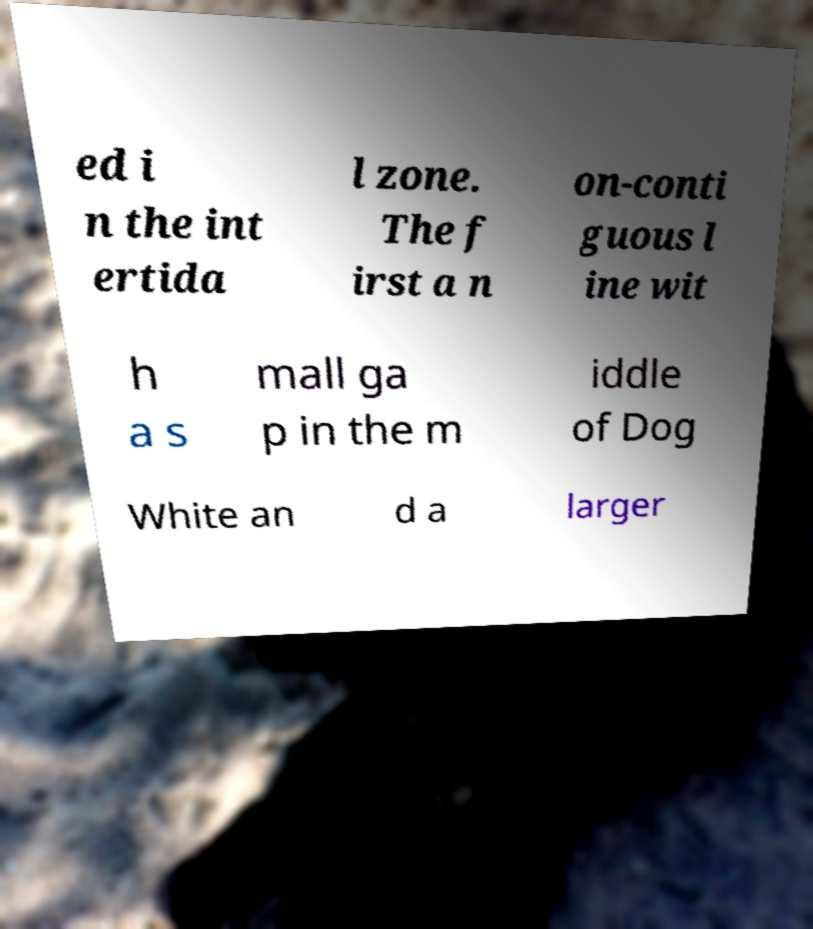Could you extract and type out the text from this image? ed i n the int ertida l zone. The f irst a n on-conti guous l ine wit h a s mall ga p in the m iddle of Dog White an d a larger 